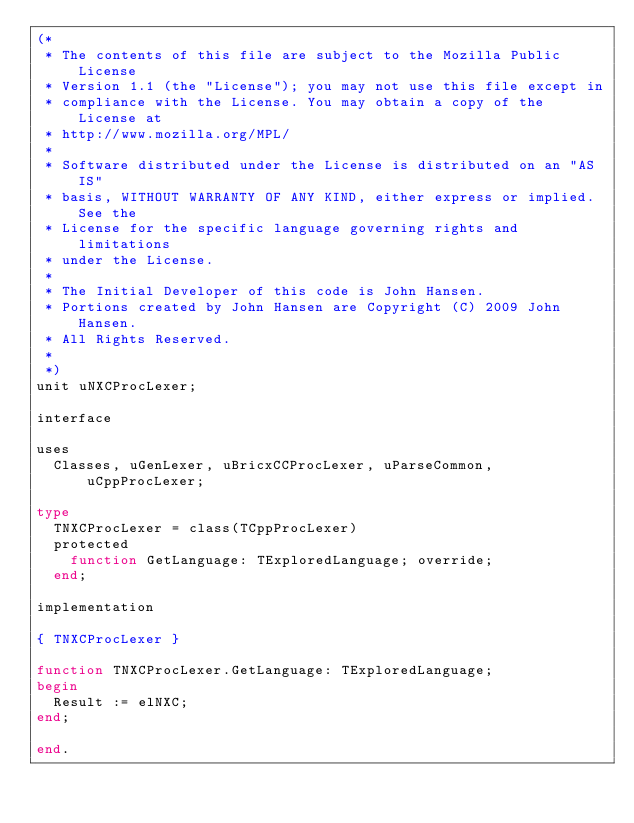<code> <loc_0><loc_0><loc_500><loc_500><_Pascal_>(*
 * The contents of this file are subject to the Mozilla Public License
 * Version 1.1 (the "License"); you may not use this file except in
 * compliance with the License. You may obtain a copy of the License at
 * http://www.mozilla.org/MPL/
 *
 * Software distributed under the License is distributed on an "AS IS"
 * basis, WITHOUT WARRANTY OF ANY KIND, either express or implied. See the
 * License for the specific language governing rights and limitations
 * under the License.
 *
 * The Initial Developer of this code is John Hansen.
 * Portions created by John Hansen are Copyright (C) 2009 John Hansen.
 * All Rights Reserved.
 *
 *)
unit uNXCProcLexer;

interface

uses
  Classes, uGenLexer, uBricxCCProcLexer, uParseCommon, uCppProcLexer;

type
  TNXCProcLexer = class(TCppProcLexer)
  protected
    function GetLanguage: TExploredLanguage; override;
  end;

implementation

{ TNXCProcLexer }

function TNXCProcLexer.GetLanguage: TExploredLanguage;
begin
  Result := elNXC;
end;

end.
</code> 